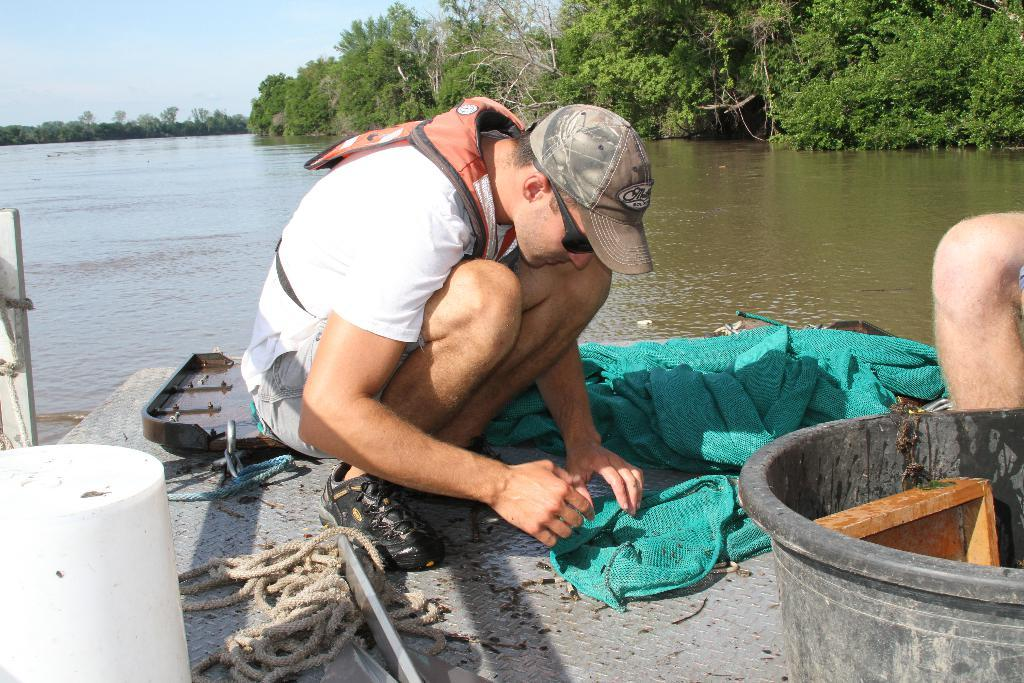What is the man in the image doing? The man is sitting in the image. What is the man wearing? The man is wearing clothes. What object can be seen in the image that is typically used for tying or securing things? There is a rope in the image. What material is present in the image that can be used for covering or wrapping? There is cloth in the image. What object in the image might be used for holding or storing items? There is a container in the image. What type of natural environment is visible in the image? There are trees and water visible in the image. What part of the natural environment is visible in the image? The sky is visible in the image. How does the man's wound heal in the image? There is no mention of a wound in the image, so it cannot be determined how it would heal. 